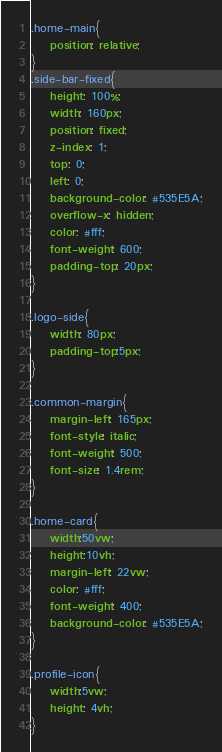Convert code to text. <code><loc_0><loc_0><loc_500><loc_500><_CSS_>.home-main{
    position: relative;
}
.side-bar-fixed{
    height: 100%;
    width: 160px;
    position: fixed;
    z-index: 1;
    top: 0;
    left: 0;
    background-color: #535E5A;
    overflow-x: hidden;
    color: #fff;
    font-weight: 600;
    padding-top: 20px;
}

.logo-side{
    width: 80px;
    padding-top:5px;
}

.common-margin{
    margin-left: 165px;
    font-style: italic;
    font-weight: 500;
    font-size: 1.4rem;
}

.home-card{
    width:50vw;
    height:10vh;
    margin-left: 22vw;
    color: #fff;
    font-weight: 400;
    background-color: #535E5A;
}

.profile-icon{
    width:5vw;
    height: 4vh;
}</code> 